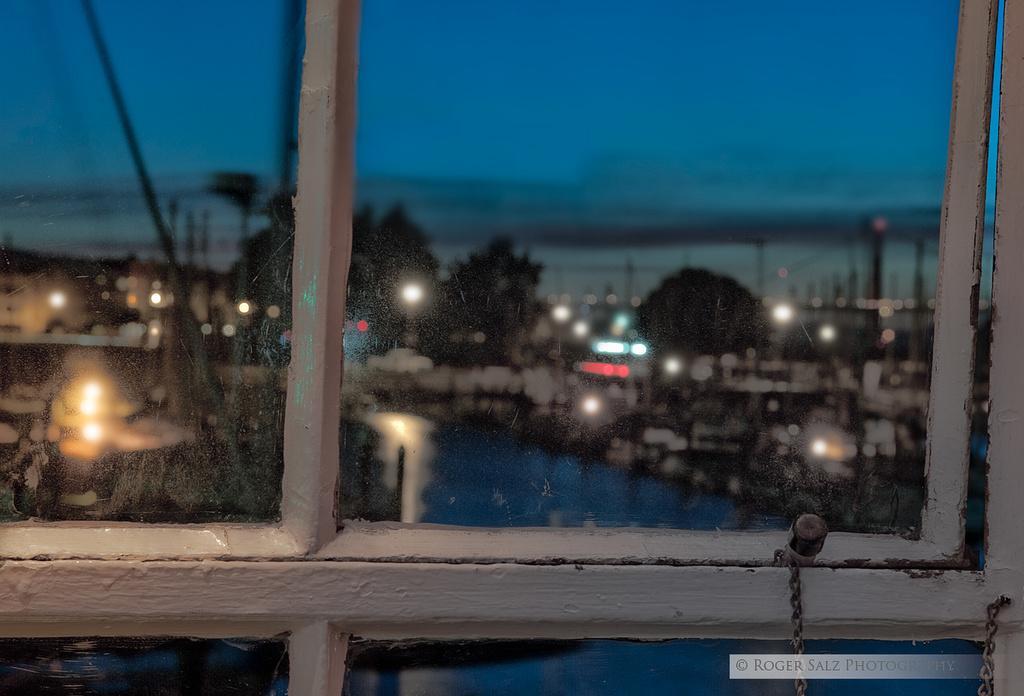How would you summarize this image in a sentence or two? In this image there is a window and we can see trees, buildings, river, lights and sky through the window glass. 